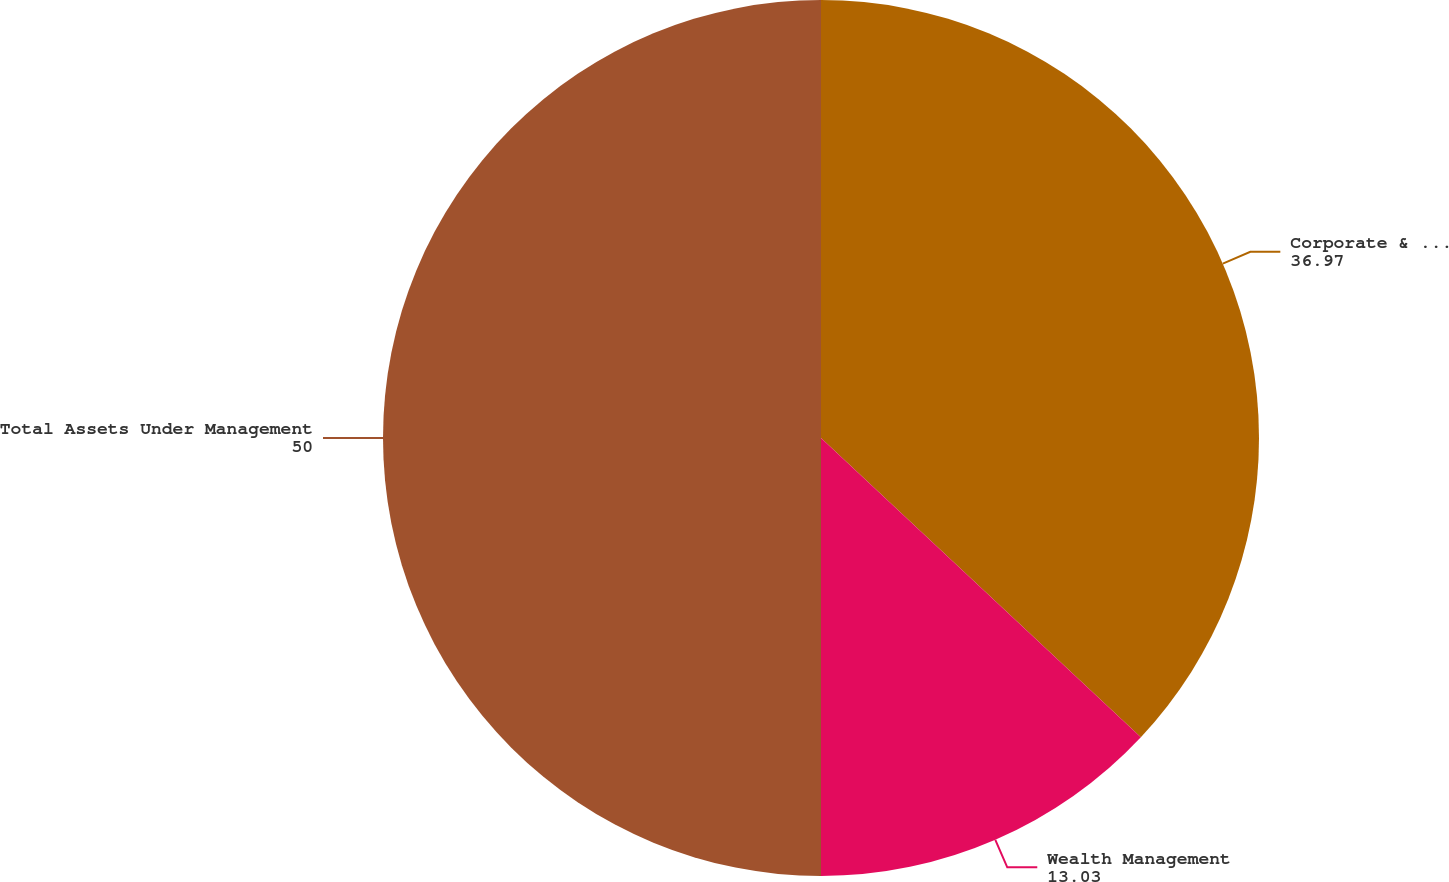Convert chart to OTSL. <chart><loc_0><loc_0><loc_500><loc_500><pie_chart><fcel>Corporate & Institutional<fcel>Wealth Management<fcel>Total Assets Under Management<nl><fcel>36.97%<fcel>13.03%<fcel>50.0%<nl></chart> 